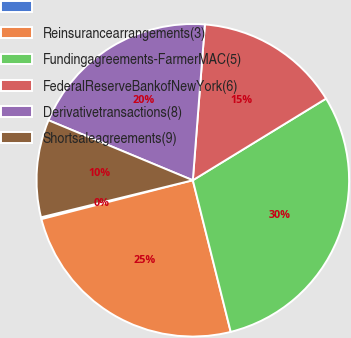Convert chart. <chart><loc_0><loc_0><loc_500><loc_500><pie_chart><ecel><fcel>Reinsurancearrangements(3)<fcel>Fundingagreements-FarmerMAC(5)<fcel>FederalReserveBankofNewYork(6)<fcel>Derivativetransactions(8)<fcel>Shortsaleagreements(9)<nl><fcel>0.19%<fcel>24.9%<fcel>29.85%<fcel>15.02%<fcel>19.96%<fcel>10.08%<nl></chart> 